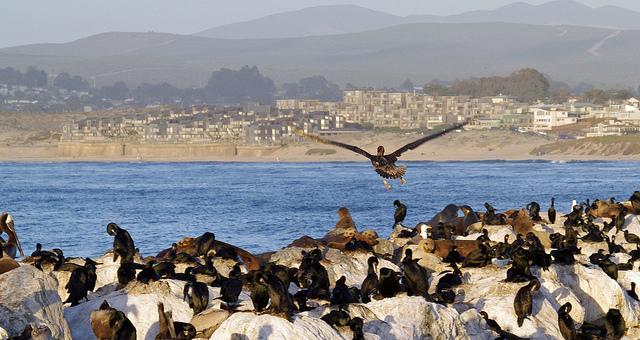Is there a lot of penguins in this picture?
Be succinct. Yes. How many birds are flying?
Answer briefly. 1. What can you see on the other side of the water?
Be succinct. City. 